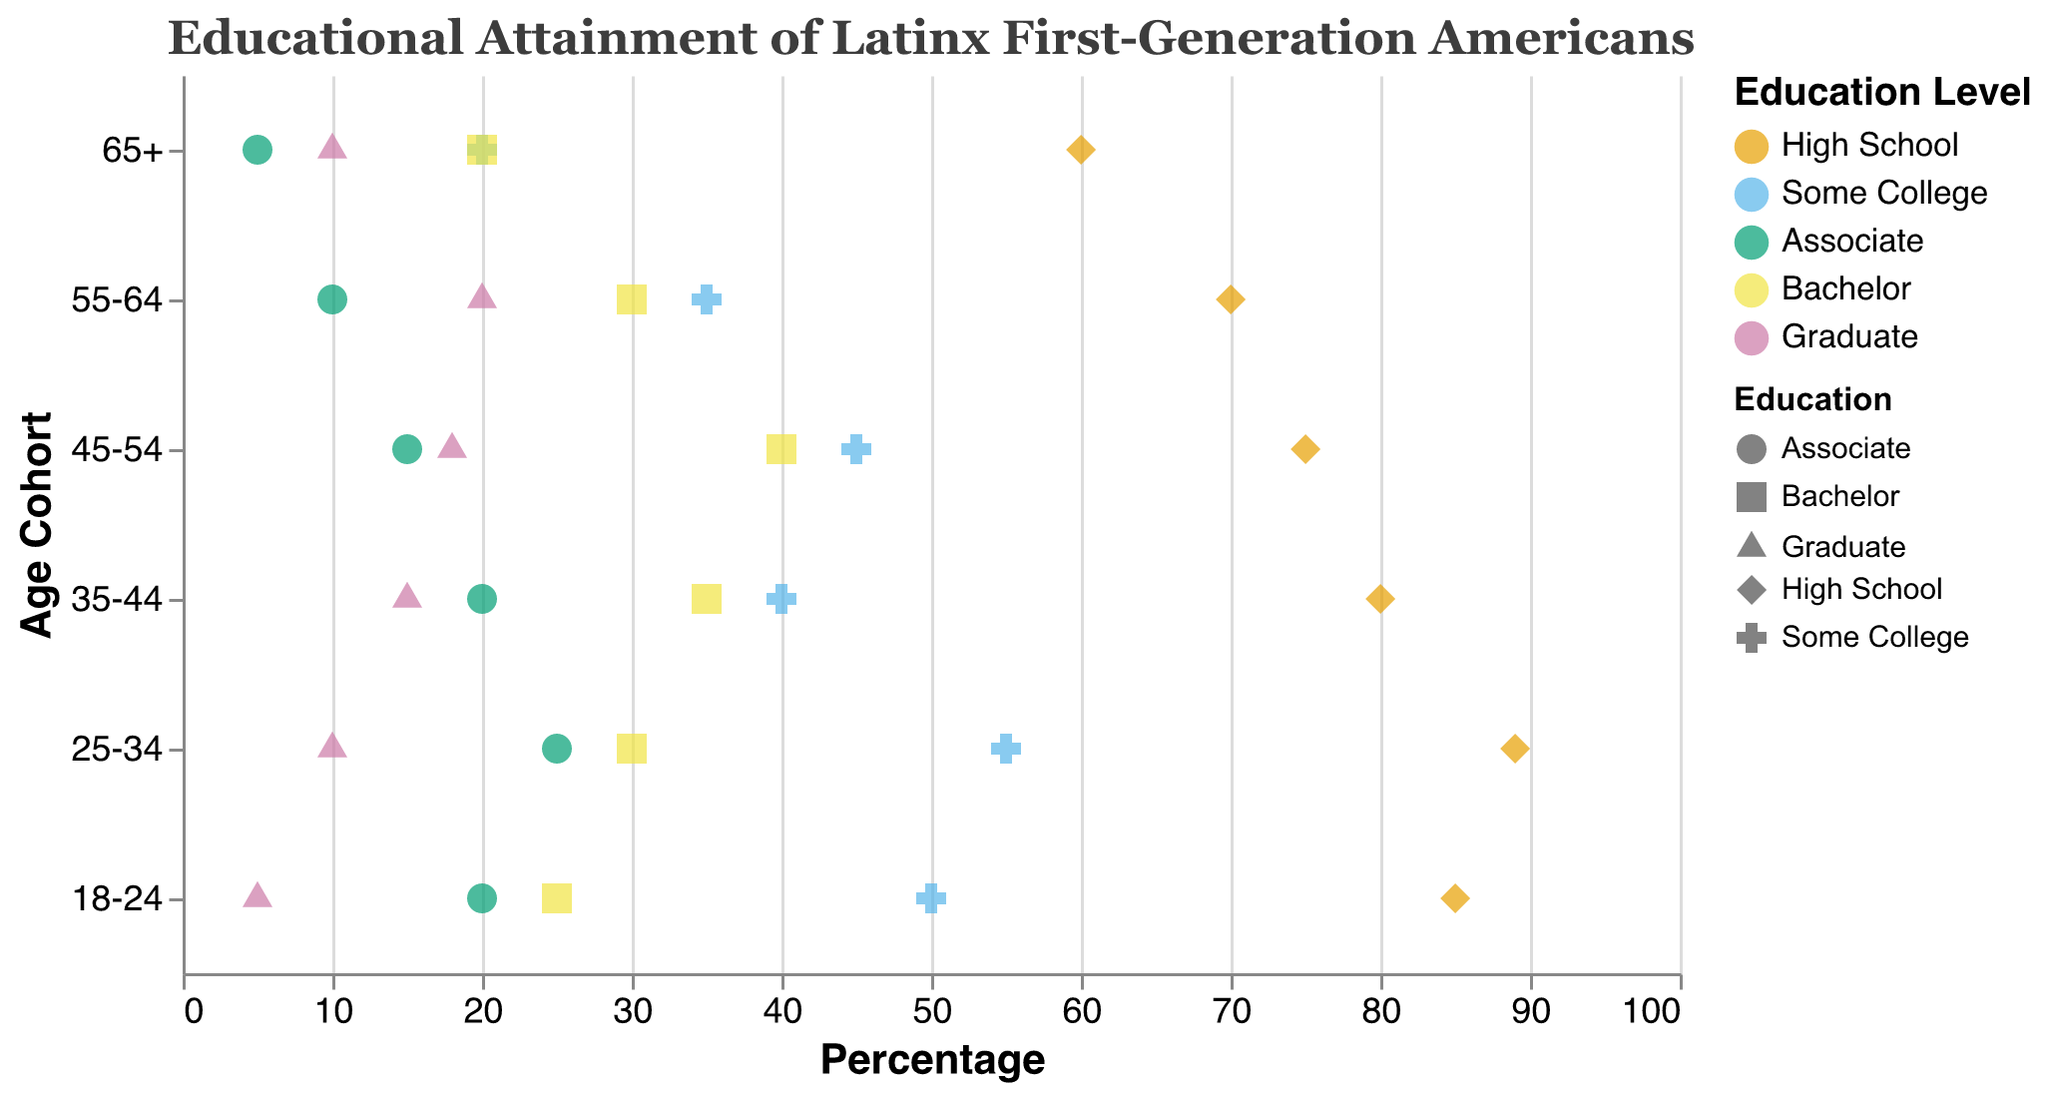What is the title of the figure? The title can be found at the top of the figure. It is "Educational Attainment of Latinx First-Generation Americans".
Answer: Educational Attainment of Latinx First-Generation Americans Which age cohort has the lowest percentage of High School attainment? By examining the High School attainment percentages, the cohort with the lowest value is 65+ with 60%.
Answer: 65+ What is the percentage of Bachelor's degree attainment in the 45-54 age cohort? Look for the Bachelor's degree attainment value in the 45-54 age cohort row, which is 40%.
Answer: 40% How does the Associate degree attainment change from the 25-34 age cohort to the 55-64 age cohort? Compare the Associate degree percentages: 25% for the 25-34 cohort and 10% for the 55-64 cohort. The change is 25% - 10% = 15%.
Answer: 15% Which age cohort has the highest percentage of Graduate degrees? Compare the Graduate degree percentages across all age cohorts. The 55-64 cohort has the highest at 20%.
Answer: 55-64 What is the range of High School attainment percentages across all age cohorts? The maximum percentage is 89% (25-34 cohort) and the minimum is 60% (65+ cohort). The range is 89% - 60% = 29%.
Answer: 29% Among the 18-24 and 35-44 cohorts, which one has a higher percentage of Some College attainment? The percentage of Some College attainment is 50% for 18-24 and 40% for 35-44. So, 18-24 has a higher percentage.
Answer: 18-24 How many education levels are represented in the plot? Examine the legend or the various shapes and colors used. There are five education levels: High School, Some College, Associate, Bachelor, and Graduate.
Answer: 5 What is the median percentage of Bachelor's degree attainment across all age cohorts? List the Bachelor's degree percentages: 25%, 30%, 35%, 40%, 30%, 20%. The median is the average of the two middle values, 30% and 30%, which is (30% + 30%) / 2 = 30%.
Answer: 30% 